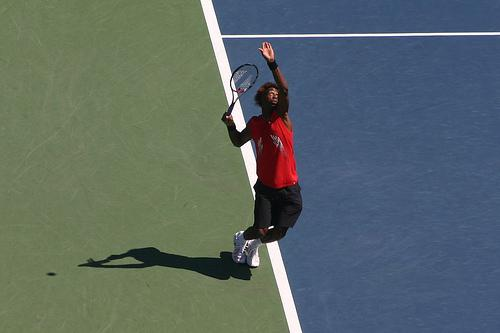Question: why is the man's hand raised?
Choices:
A. He's waving.
B. He's changing his shirt.
C. He has just thrown up a tennis ball.
D. He's under arrest.
Answer with the letter. Answer: C Question: how was this picture taken?
Choices:
A. Secretly.
B. Camera.
C. In a photo shoot.
D. Slow speed.
Answer with the letter. Answer: B Question: what is the man doing in the photograph?
Choices:
A. Playing tennis.
B. Jogging.
C. Surfing.
D. Skiing.
Answer with the letter. Answer: A Question: what was the weather like in this photo?
Choices:
A. Rainy.
B. Gray.
C. Snowy.
D. Sunny.
Answer with the letter. Answer: D Question: what is the object in the man's hands?
Choices:
A. Hockey stick.
B. Surfboard.
C. A tennis racquet.
D. Baseball glove.
Answer with the letter. Answer: C Question: who is the man in the photo?
Choices:
A. A surfer.
B. A jogger.
C. A wrestler.
D. A tennis player.
Answer with the letter. Answer: D Question: where was this picture taken?
Choices:
A. At the club.
B. On a tennis court.
C. In the arena.
D. In the park.
Answer with the letter. Answer: B 